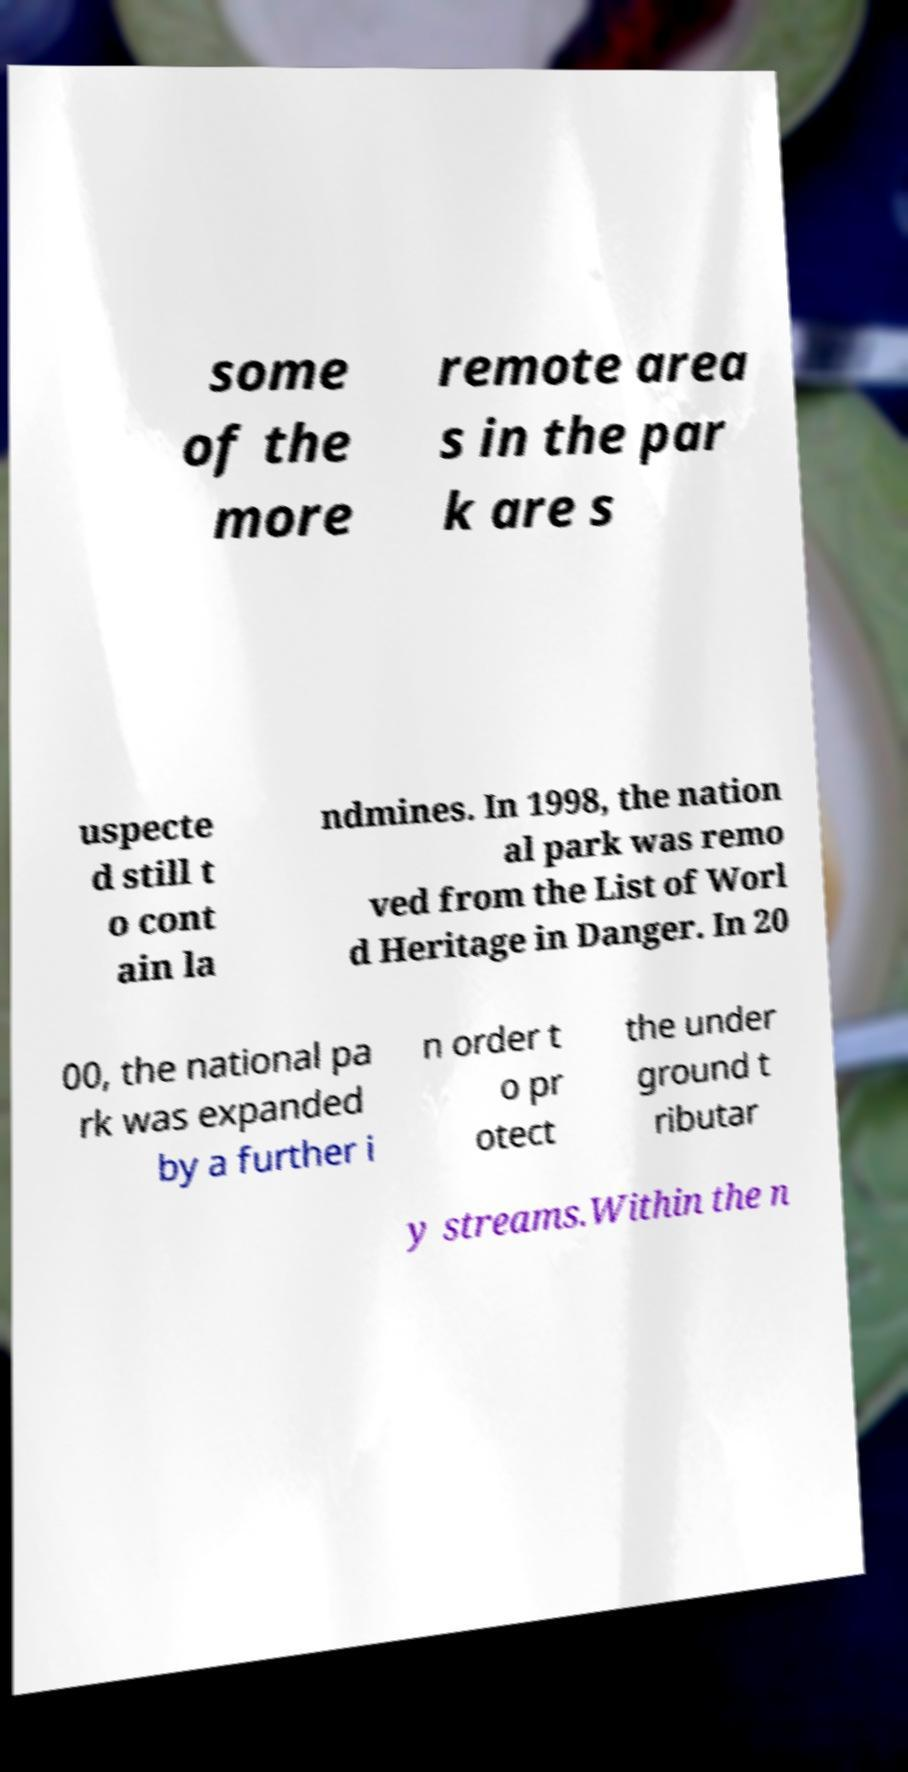Could you assist in decoding the text presented in this image and type it out clearly? some of the more remote area s in the par k are s uspecte d still t o cont ain la ndmines. In 1998, the nation al park was remo ved from the List of Worl d Heritage in Danger. In 20 00, the national pa rk was expanded by a further i n order t o pr otect the under ground t ributar y streams.Within the n 